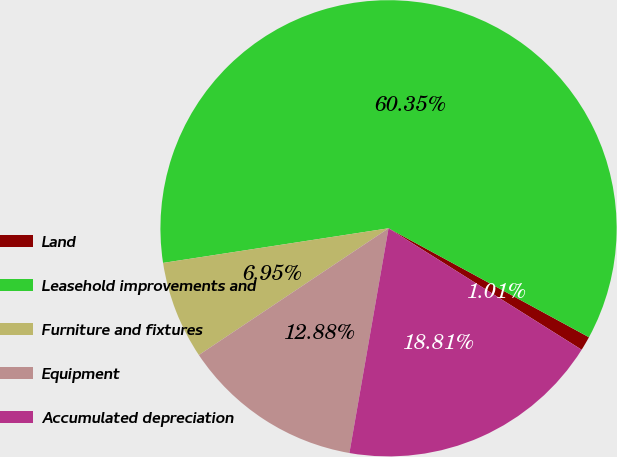Convert chart. <chart><loc_0><loc_0><loc_500><loc_500><pie_chart><fcel>Land<fcel>Leasehold improvements and<fcel>Furniture and fixtures<fcel>Equipment<fcel>Accumulated depreciation<nl><fcel>1.01%<fcel>60.35%<fcel>6.95%<fcel>12.88%<fcel>18.81%<nl></chart> 